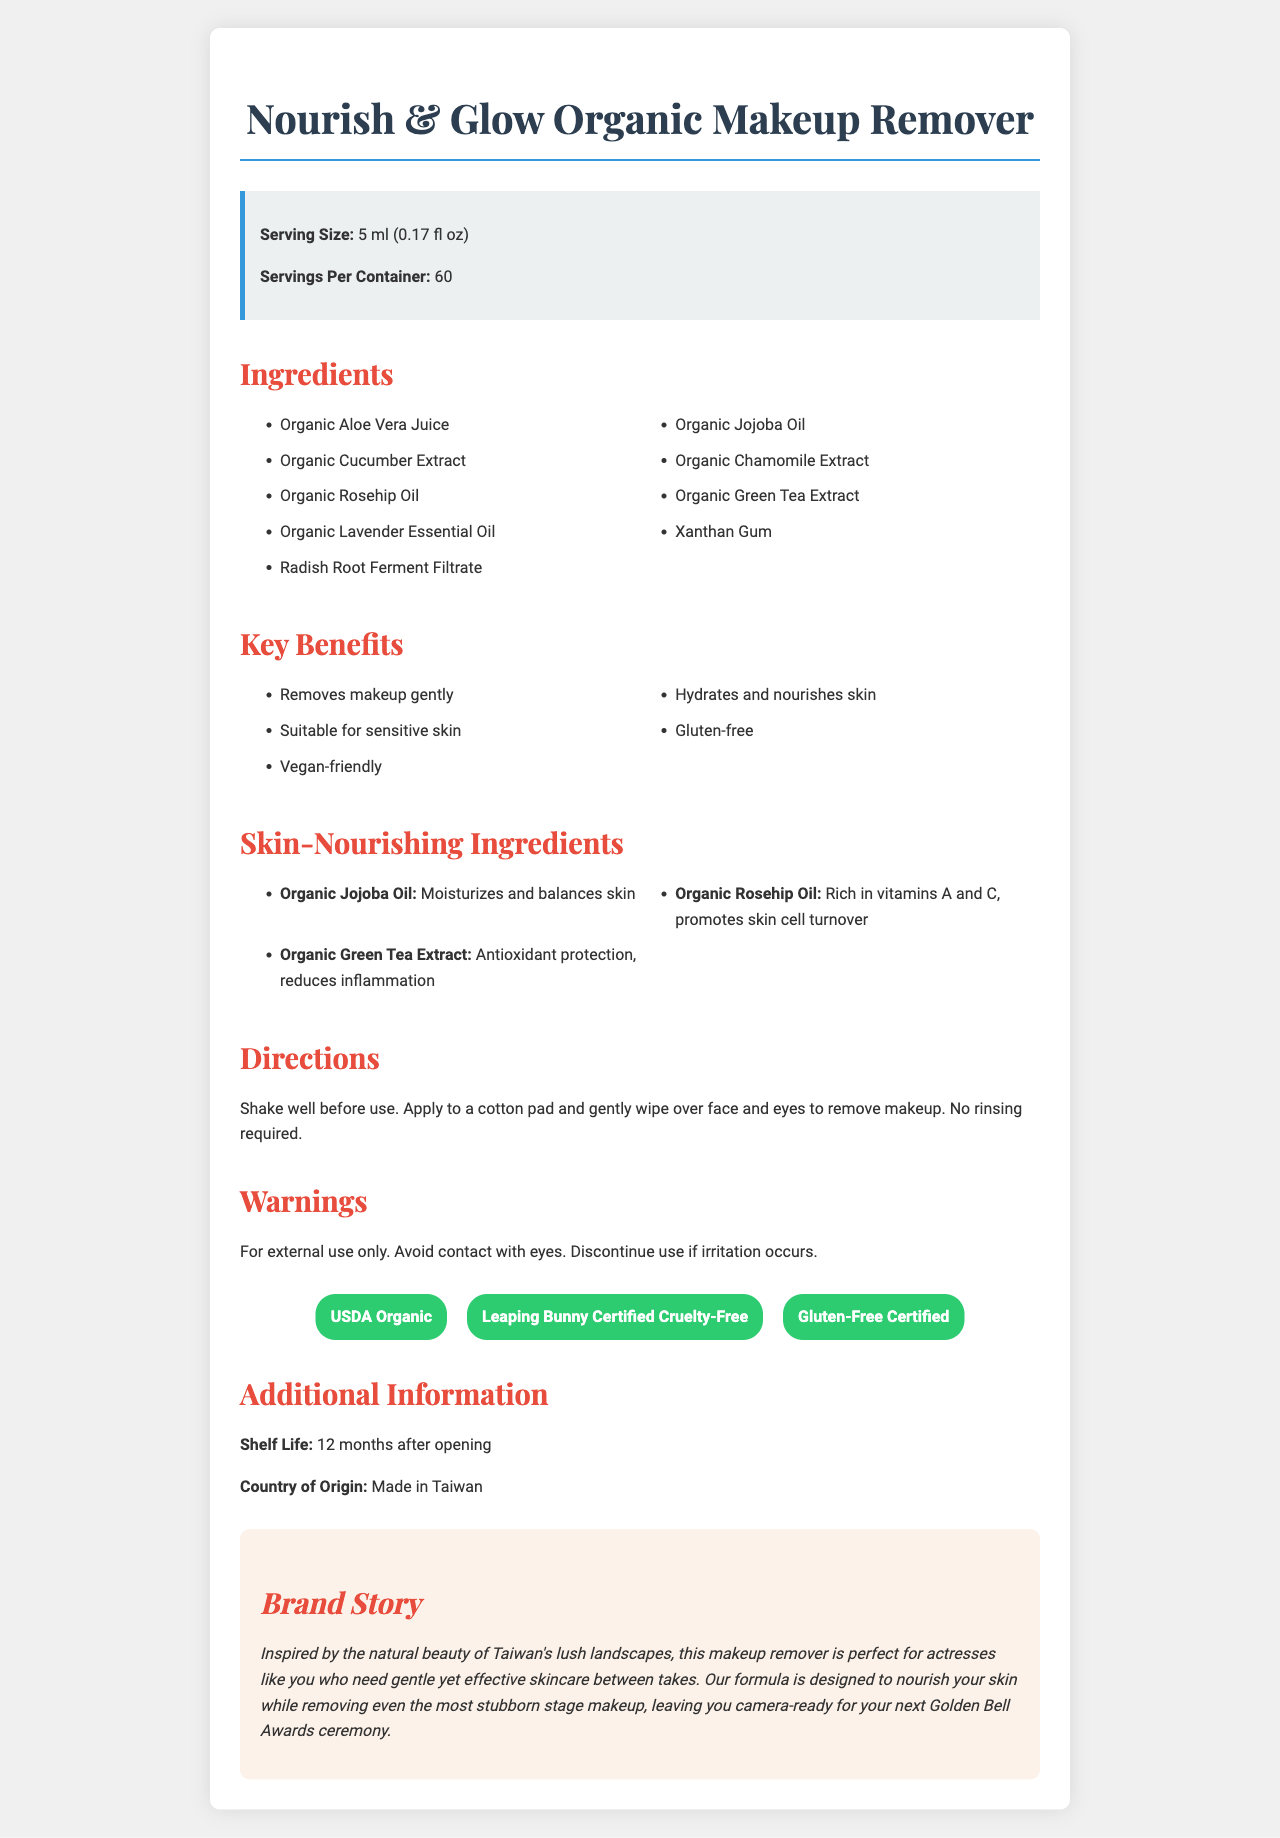what is the serving size of the Nourish & Glow Organic Makeup Remover? The serving size is clearly listed under the "Serving Size" section.
Answer: 5 ml (0.17 fl oz) how many servings are there per container of this makeup remover? This information is noted under "Servings Per Container" in the document.
Answer: 60 what are the key benefits of using this makeup remover? These benefits are listed under the "Key Benefits" section.
Answer: Removes makeup gently, Hydrates and nourishes skin, Suitable for sensitive skin, Gluten-free, Vegan-friendly what is one of the skin-nourishing ingredients in this product and its benefit? This is listed under the section "Skin-Nourishing Ingredients."
Answer: Organic Jojoba Oil: Moisturizes and balances skin how should the makeup remover be used? The directions for use are provided under "Directions."
Answer: Shake well before use. Apply to a cotton pad and gently wipe over face and eyes to remove makeup. No rinsing required. where is this makeup remover made? This information is listed under "Country of Origin."
Answer: Made in Taiwan how should the makeup remover be stored after opening? The storage information post-opening is noted in the "Additional Information" section.
Answer: Shelf Life: 12 months after opening which of the following is NOT an ingredient in the makeup remover? A. Organic Aloe Vera Juice B. Organic Lavender Essential Oil C. Organic Coconut Oil Organic Coconut Oil is not listed among the ingredients.
Answer: C. Organic Coconut Oil what is one certification this product has? A. USDA Organic B. Certified Kosher C. Fair Trade Certified USDA Organic is one of the certifications listed under "Certifications".
Answer: A. USDA Organic does this product contain any gluten? The product is noted as gluten-free under the "Key Benefits" and "Certifications" sections.
Answer: No is this product suitable for sensitive skin? The document states "Suitable for sensitive skin" under "Key Benefits."
Answer: Yes summarize the purpose and key features of this document. The document is comprehensive, detailing product ingredients, usage instructions, benefits, safety warnings, certifications, and the brand story. It is designed to inform potential users about the makeup remover's features and advantages.
Answer: The document provides comprehensive information about the Nourish & Glow Organic Makeup Remover, including its serving size, servings per container, ingredients, key benefits, skin-nourishing ingredients, directions for use, warnings, certifications, shelf life, country of origin, and brand story. what are some benefits of using the organic ingredients in this product? The specific benefits of using organic ingredients like Organic Aloe Vera Juice, Organic Jojoba Oil, etc., in a makeup remover are not detailed beyond individual ingredient benefits. There is no detailed comparison to non-organic ingredients in the document.
Answer: Cannot be determined 